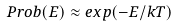<formula> <loc_0><loc_0><loc_500><loc_500>P r o b ( E ) \approx e x p ( - E / k T )</formula> 